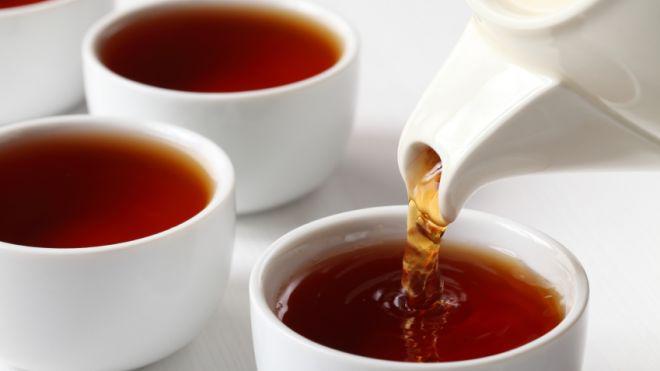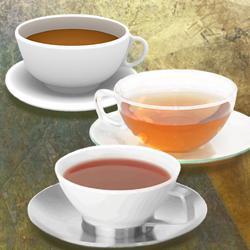The first image is the image on the left, the second image is the image on the right. Evaluate the accuracy of this statement regarding the images: "tea is being poured from a spout". Is it true? Answer yes or no. Yes. The first image is the image on the left, the second image is the image on the right. Evaluate the accuracy of this statement regarding the images: "Tea is being poured from a teapot into one of the white tea cups.". Is it true? Answer yes or no. Yes. 